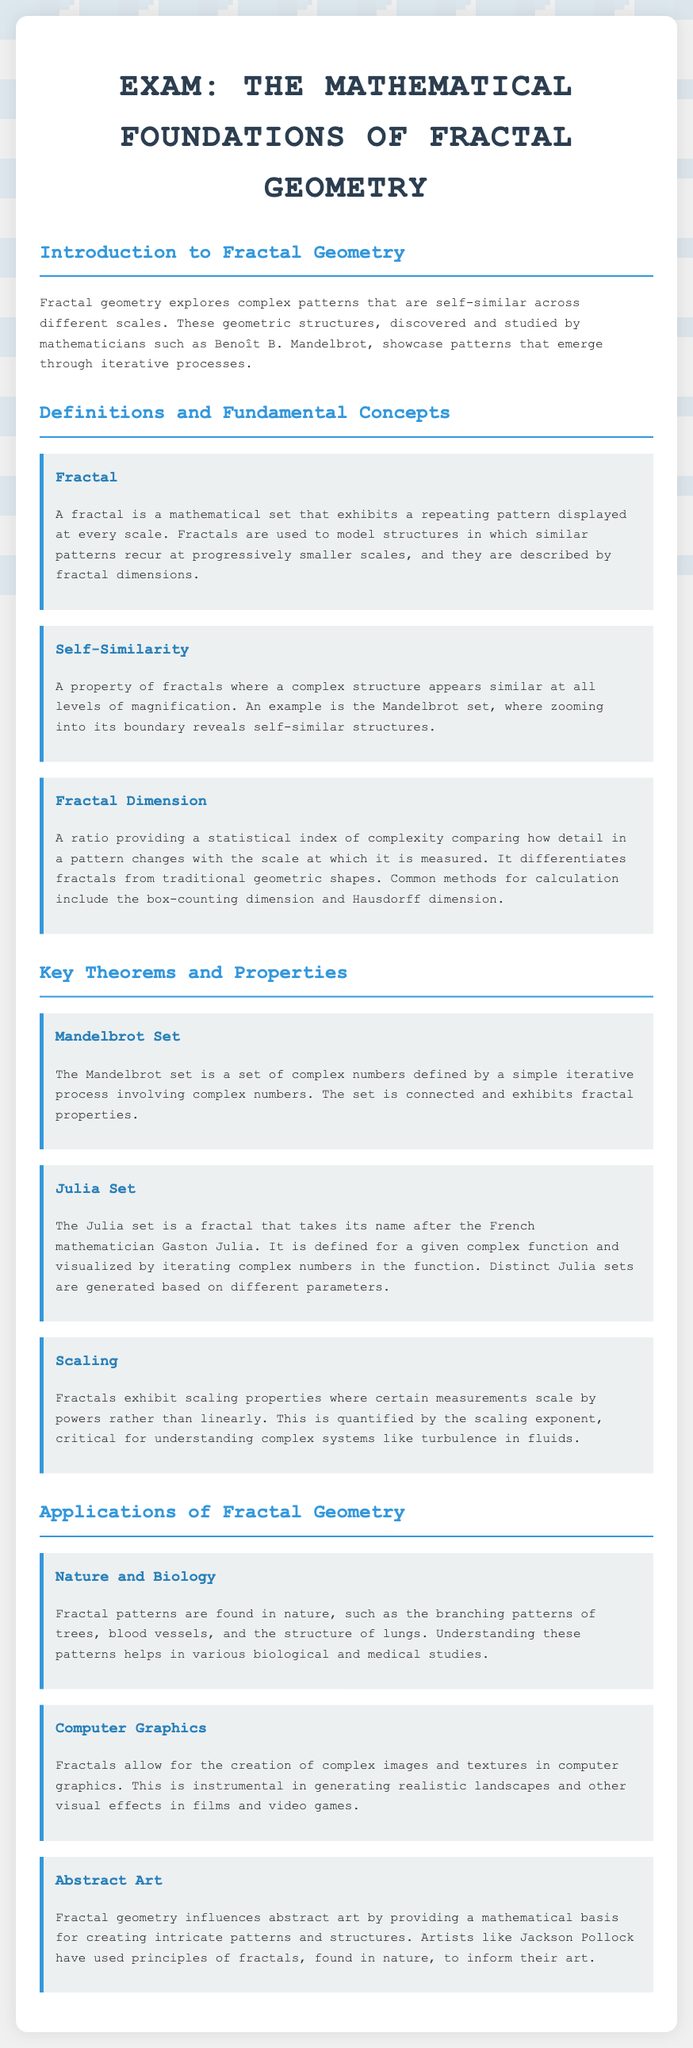What is a fractal? A fractal is defined in the document as a mathematical set that exhibits a repeating pattern displayed at every scale.
Answer: A fractal is a mathematical set that exhibits a repeating pattern displayed at every scale What is the significance of the Mandelbrot set? The document states that the Mandelbrot set is a set of complex numbers defined by a simple iterative process involving complex numbers, thus highlighting its fractal properties.
Answer: The Mandelbrot set is a set of complex numbers defined by a simple iterative process involving complex numbers What type of patterns do fractals exhibit? According to the document, fractals exhibit scaling properties where certain measurements scale by powers rather than linearly.
Answer: Scaling properties What is the fractal dimension? The document describes the fractal dimension as a ratio providing a statistical index of complexity comparing how detail in a pattern changes with the scale at which it is measured.
Answer: A ratio providing a statistical index of complexity Who studied the Mandelbrot set? The document notes that the Mandelbrot set was studied by Benoît B. Mandelbrot.
Answer: Benoît B. Mandelbrot What mathematical concept directly relates to the definition of self-similarity in fractals? The document mentions self-similarity as a property of fractals where a complex structure appears similar at all levels of magnification.
Answer: Similar at all levels of magnification In which area is fractal geometry applied according to the document? The document lists several applications of fractal geometry, including nature and biology, computer graphics, and abstract art.
Answer: Nature and biology, computer graphics, and abstract art 